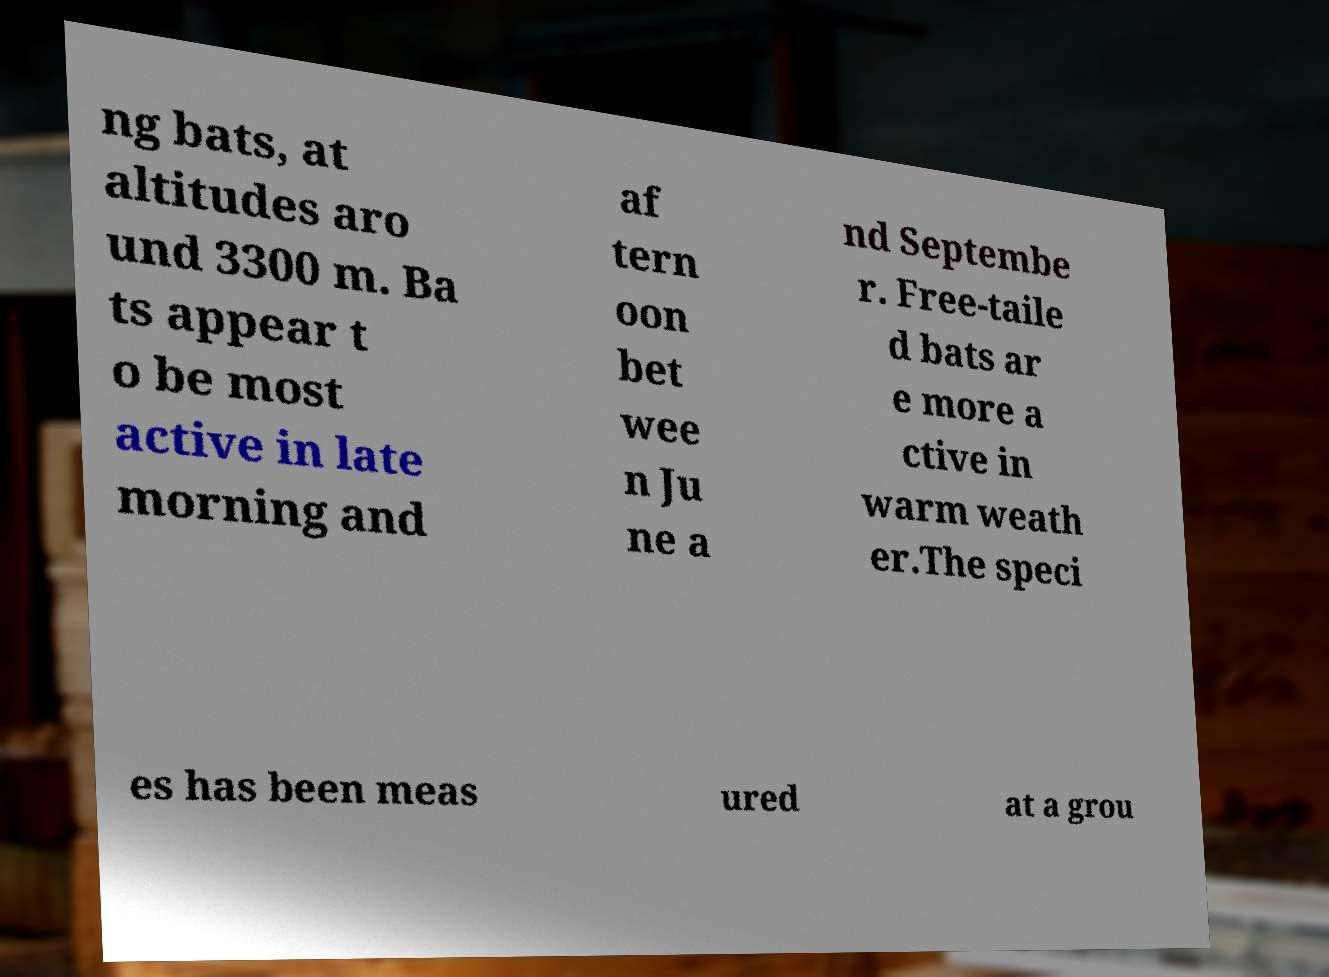What messages or text are displayed in this image? I need them in a readable, typed format. ng bats, at altitudes aro und 3300 m. Ba ts appear t o be most active in late morning and af tern oon bet wee n Ju ne a nd Septembe r. Free-taile d bats ar e more a ctive in warm weath er.The speci es has been meas ured at a grou 